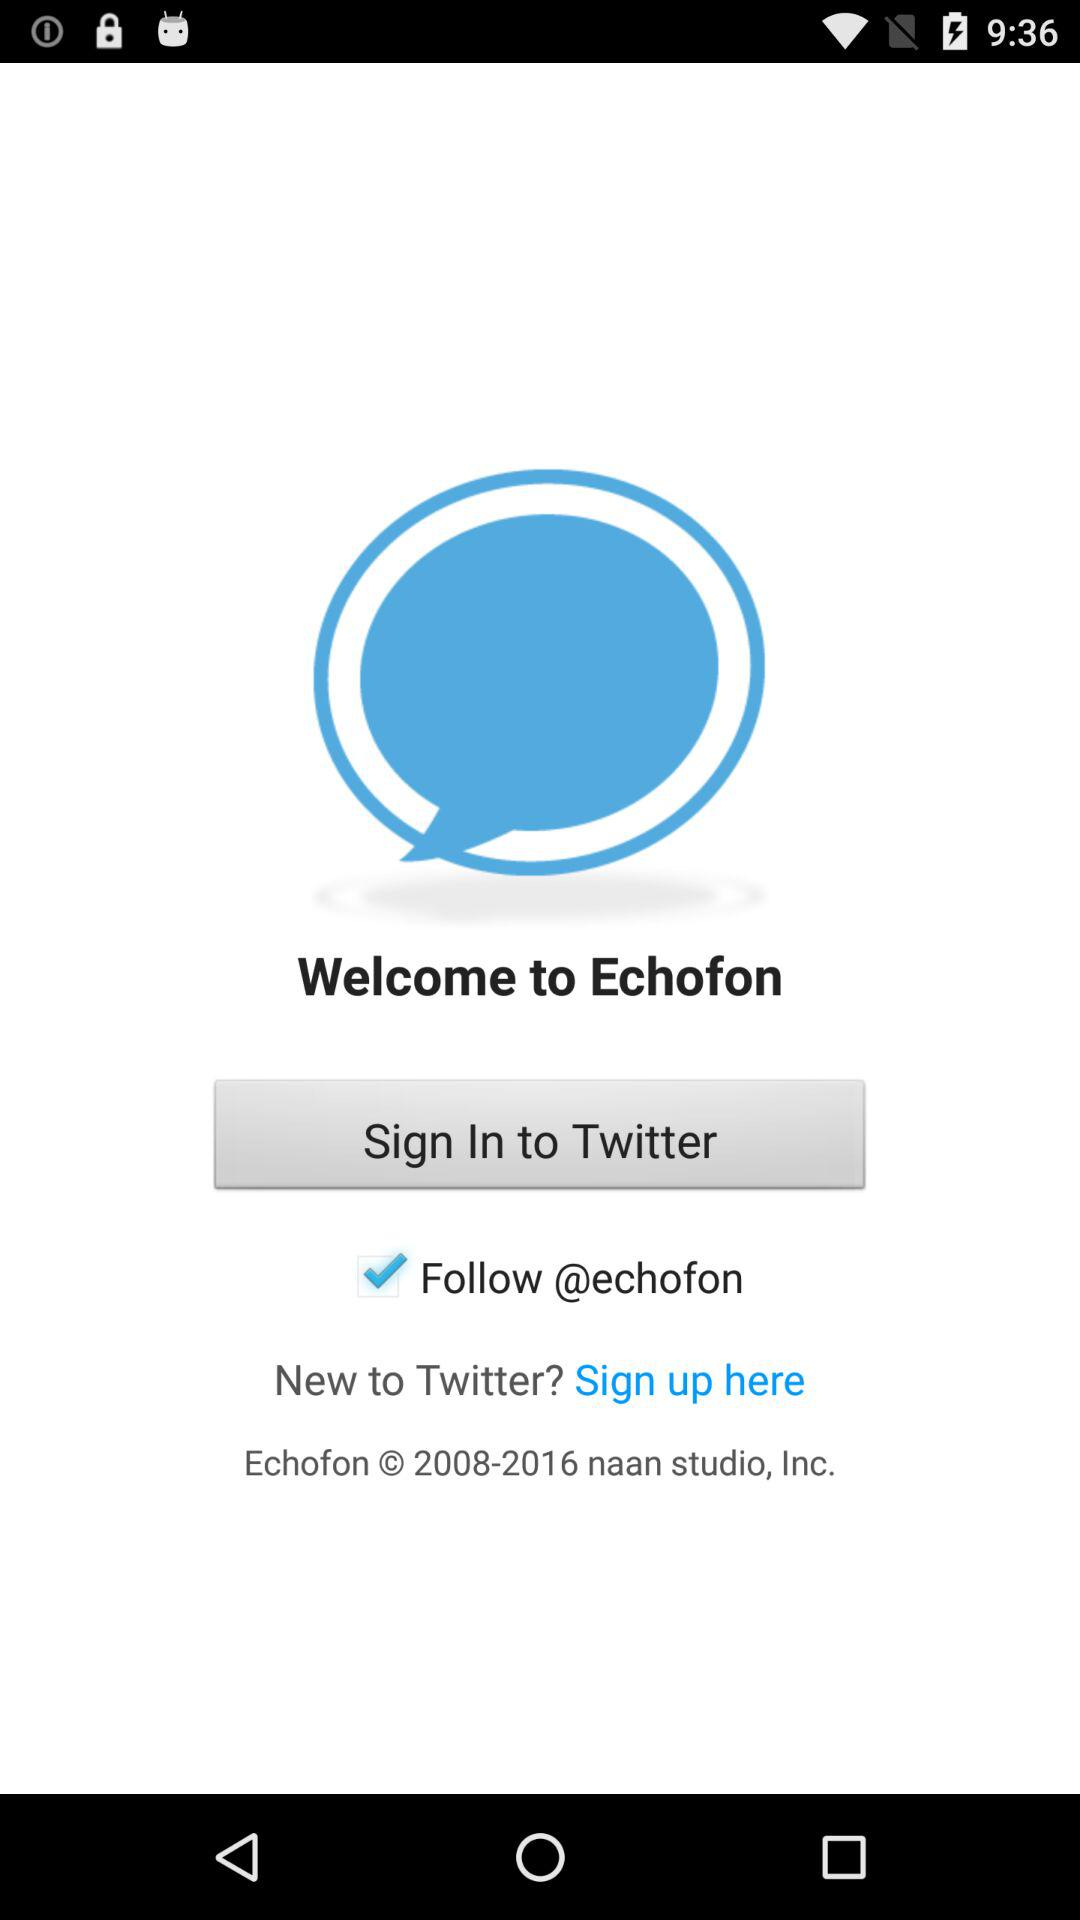What’s the app name?
Answer the question using a single word or phrase. The names of the apps are "Echofon" and "Twitter." 